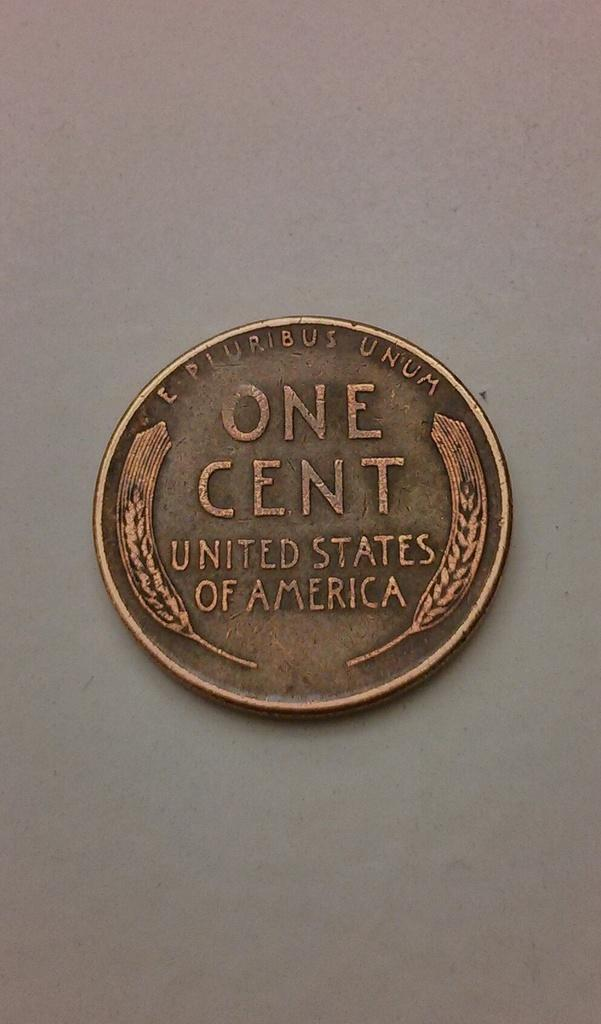<image>
Offer a succinct explanation of the picture presented. An old one cent coin from US currency. 